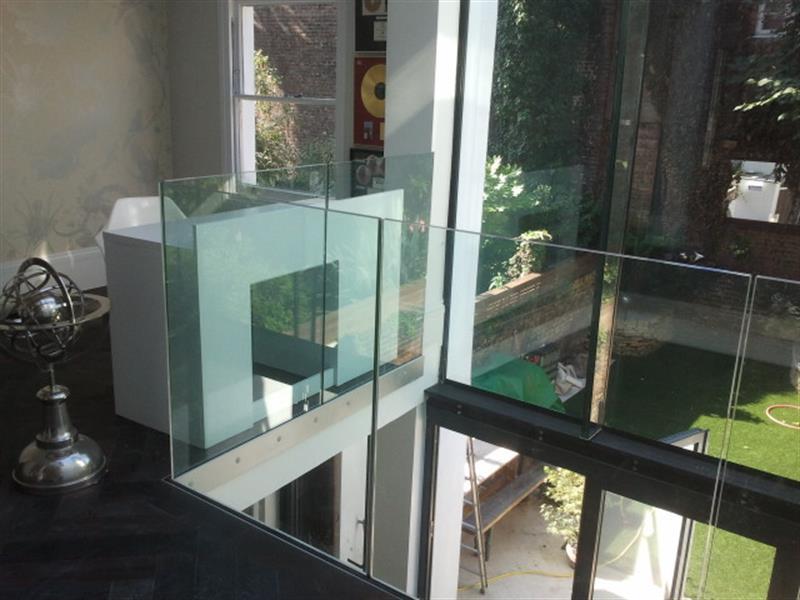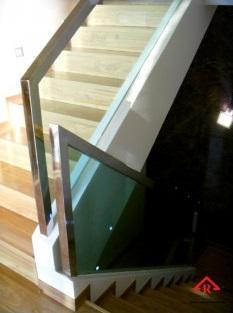The first image is the image on the left, the second image is the image on the right. Examine the images to the left and right. Is the description "An image shows a stairwell enclosed by glass panels without a top rail or hinges." accurate? Answer yes or no. Yes. 